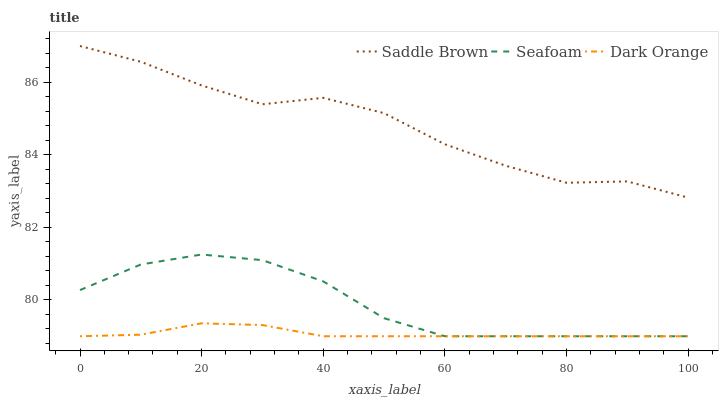Does Dark Orange have the minimum area under the curve?
Answer yes or no. Yes. Does Saddle Brown have the maximum area under the curve?
Answer yes or no. Yes. Does Seafoam have the minimum area under the curve?
Answer yes or no. No. Does Seafoam have the maximum area under the curve?
Answer yes or no. No. Is Dark Orange the smoothest?
Answer yes or no. Yes. Is Saddle Brown the roughest?
Answer yes or no. Yes. Is Seafoam the smoothest?
Answer yes or no. No. Is Seafoam the roughest?
Answer yes or no. No. Does Dark Orange have the lowest value?
Answer yes or no. Yes. Does Saddle Brown have the lowest value?
Answer yes or no. No. Does Saddle Brown have the highest value?
Answer yes or no. Yes. Does Seafoam have the highest value?
Answer yes or no. No. Is Seafoam less than Saddle Brown?
Answer yes or no. Yes. Is Saddle Brown greater than Dark Orange?
Answer yes or no. Yes. Does Seafoam intersect Dark Orange?
Answer yes or no. Yes. Is Seafoam less than Dark Orange?
Answer yes or no. No. Is Seafoam greater than Dark Orange?
Answer yes or no. No. Does Seafoam intersect Saddle Brown?
Answer yes or no. No. 